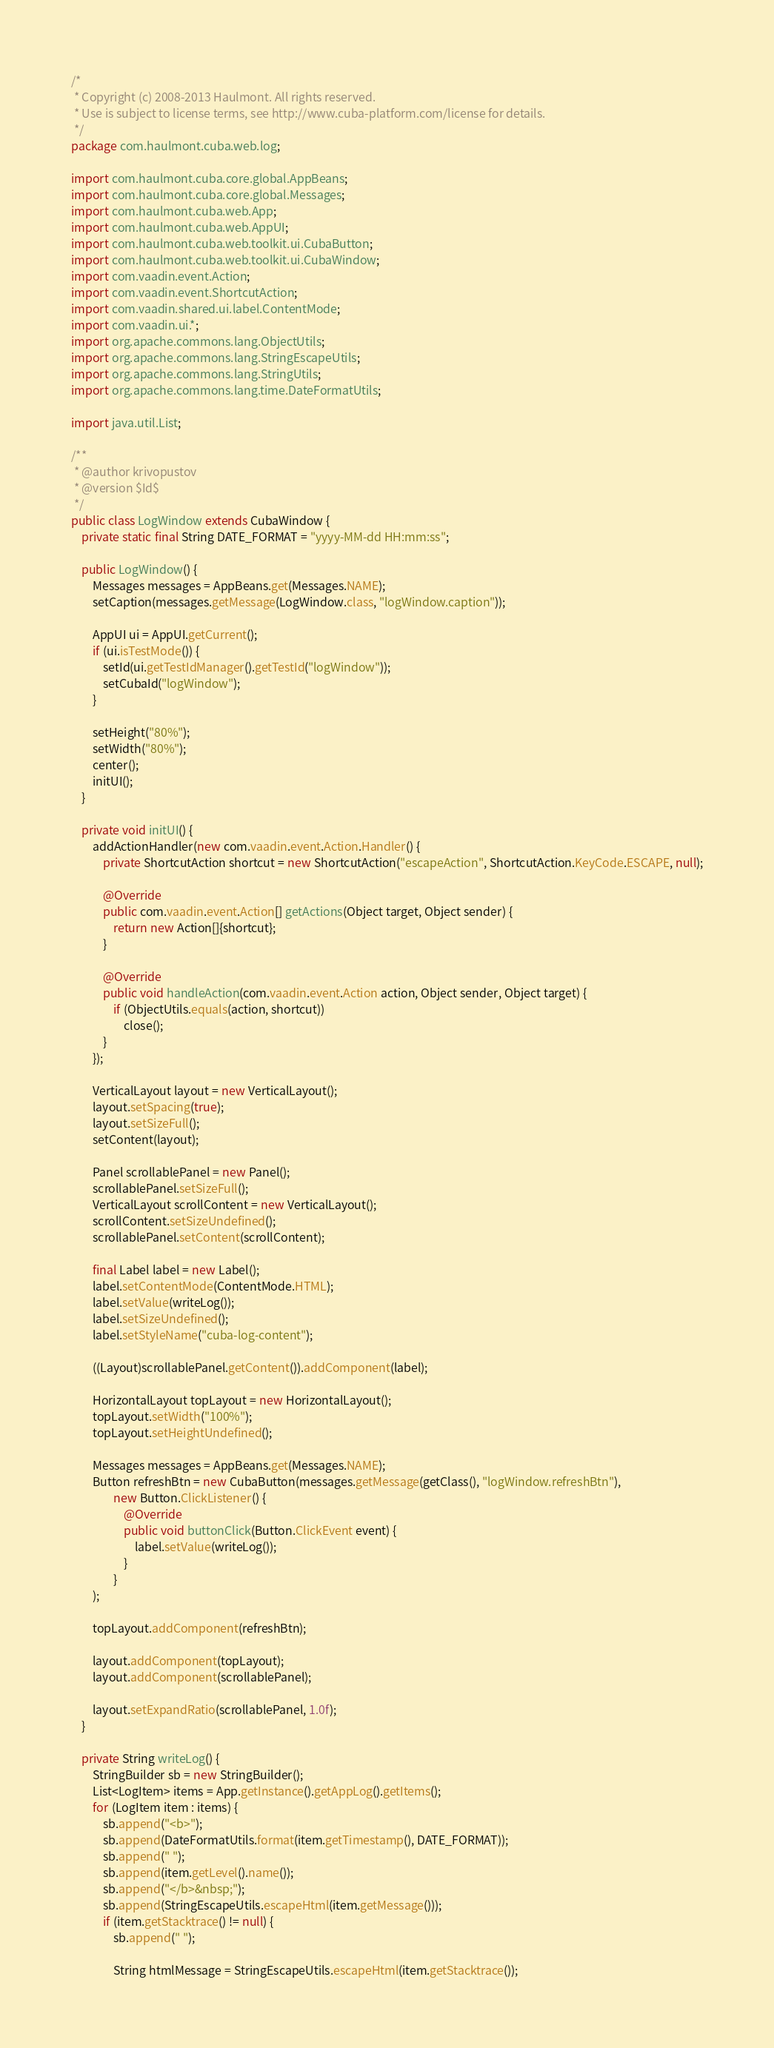<code> <loc_0><loc_0><loc_500><loc_500><_Java_>/*
 * Copyright (c) 2008-2013 Haulmont. All rights reserved.
 * Use is subject to license terms, see http://www.cuba-platform.com/license for details.
 */
package com.haulmont.cuba.web.log;

import com.haulmont.cuba.core.global.AppBeans;
import com.haulmont.cuba.core.global.Messages;
import com.haulmont.cuba.web.App;
import com.haulmont.cuba.web.AppUI;
import com.haulmont.cuba.web.toolkit.ui.CubaButton;
import com.haulmont.cuba.web.toolkit.ui.CubaWindow;
import com.vaadin.event.Action;
import com.vaadin.event.ShortcutAction;
import com.vaadin.shared.ui.label.ContentMode;
import com.vaadin.ui.*;
import org.apache.commons.lang.ObjectUtils;
import org.apache.commons.lang.StringEscapeUtils;
import org.apache.commons.lang.StringUtils;
import org.apache.commons.lang.time.DateFormatUtils;

import java.util.List;

/**
 * @author krivopustov
 * @version $Id$
 */
public class LogWindow extends CubaWindow {
    private static final String DATE_FORMAT = "yyyy-MM-dd HH:mm:ss";

    public LogWindow() {
        Messages messages = AppBeans.get(Messages.NAME);
        setCaption(messages.getMessage(LogWindow.class, "logWindow.caption"));

        AppUI ui = AppUI.getCurrent();
        if (ui.isTestMode()) {
            setId(ui.getTestIdManager().getTestId("logWindow"));
            setCubaId("logWindow");
        }

        setHeight("80%");
        setWidth("80%");
        center();
        initUI();
    }

    private void initUI() {
        addActionHandler(new com.vaadin.event.Action.Handler() {
            private ShortcutAction shortcut = new ShortcutAction("escapeAction", ShortcutAction.KeyCode.ESCAPE, null);

            @Override
            public com.vaadin.event.Action[] getActions(Object target, Object sender) {
                return new Action[]{shortcut};
            }

            @Override
            public void handleAction(com.vaadin.event.Action action, Object sender, Object target) {
                if (ObjectUtils.equals(action, shortcut))
                    close();
            }
        });

        VerticalLayout layout = new VerticalLayout();
        layout.setSpacing(true);
        layout.setSizeFull();
        setContent(layout);

        Panel scrollablePanel = new Panel();
        scrollablePanel.setSizeFull();
        VerticalLayout scrollContent = new VerticalLayout();
        scrollContent.setSizeUndefined();
        scrollablePanel.setContent(scrollContent);

        final Label label = new Label();
        label.setContentMode(ContentMode.HTML);
        label.setValue(writeLog());
        label.setSizeUndefined();
        label.setStyleName("cuba-log-content");

        ((Layout)scrollablePanel.getContent()).addComponent(label);

        HorizontalLayout topLayout = new HorizontalLayout();
        topLayout.setWidth("100%");
        topLayout.setHeightUndefined();

        Messages messages = AppBeans.get(Messages.NAME);
        Button refreshBtn = new CubaButton(messages.getMessage(getClass(), "logWindow.refreshBtn"),
                new Button.ClickListener() {
                    @Override
                    public void buttonClick(Button.ClickEvent event) {
                        label.setValue(writeLog());
                    }
                }
        );

        topLayout.addComponent(refreshBtn);

        layout.addComponent(topLayout);
        layout.addComponent(scrollablePanel);

        layout.setExpandRatio(scrollablePanel, 1.0f);
    }

    private String writeLog() {
        StringBuilder sb = new StringBuilder();
        List<LogItem> items = App.getInstance().getAppLog().getItems();
        for (LogItem item : items) {
            sb.append("<b>");
            sb.append(DateFormatUtils.format(item.getTimestamp(), DATE_FORMAT));
            sb.append(" ");
            sb.append(item.getLevel().name());
            sb.append("</b>&nbsp;");
            sb.append(StringEscapeUtils.escapeHtml(item.getMessage()));
            if (item.getStacktrace() != null) {
                sb.append(" ");

                String htmlMessage = StringEscapeUtils.escapeHtml(item.getStacktrace());</code> 